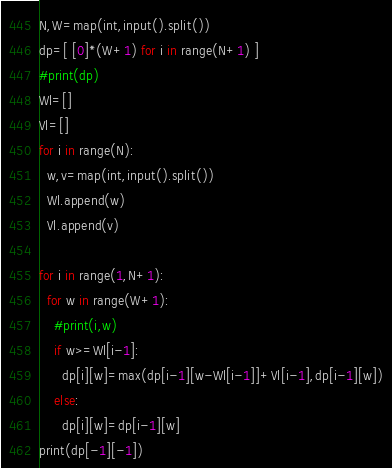Convert code to text. <code><loc_0><loc_0><loc_500><loc_500><_Python_>N,W=map(int,input().split())
dp=[ [0]*(W+1) for i in range(N+1) ]
#print(dp)
Wl=[]
Vl=[]
for i in range(N):
  w,v=map(int,input().split())
  Wl.append(w)
  Vl.append(v)

for i in range(1,N+1):
  for w in range(W+1):
    #print(i,w)
    if w>=Wl[i-1]:
      dp[i][w]=max(dp[i-1][w-Wl[i-1]]+Vl[i-1],dp[i-1][w])
    else:
      dp[i][w]=dp[i-1][w]
print(dp[-1][-1])</code> 